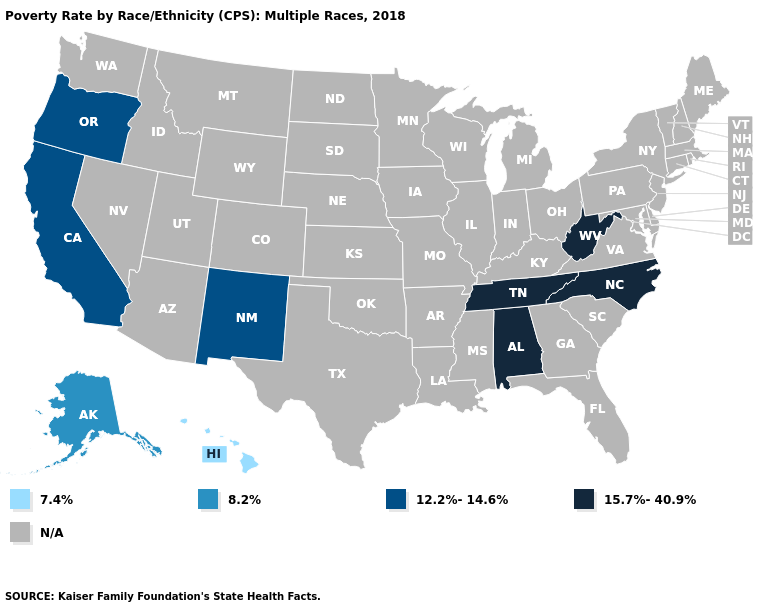Name the states that have a value in the range 15.7%-40.9%?
Be succinct. Alabama, North Carolina, Tennessee, West Virginia. What is the value of Arkansas?
Keep it brief. N/A. What is the value of Minnesota?
Be succinct. N/A. What is the value of Vermont?
Quick response, please. N/A. Does the first symbol in the legend represent the smallest category?
Short answer required. Yes. What is the highest value in the USA?
Keep it brief. 15.7%-40.9%. What is the value of Connecticut?
Be succinct. N/A. Name the states that have a value in the range 8.2%?
Write a very short answer. Alaska. 